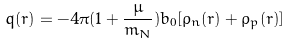<formula> <loc_0><loc_0><loc_500><loc_500>q ( r ) = - 4 \pi ( 1 + \frac { \mu } { m _ { N } } ) b _ { 0 } [ \rho _ { n } ( r ) + \rho _ { p } ( r ) ]</formula> 